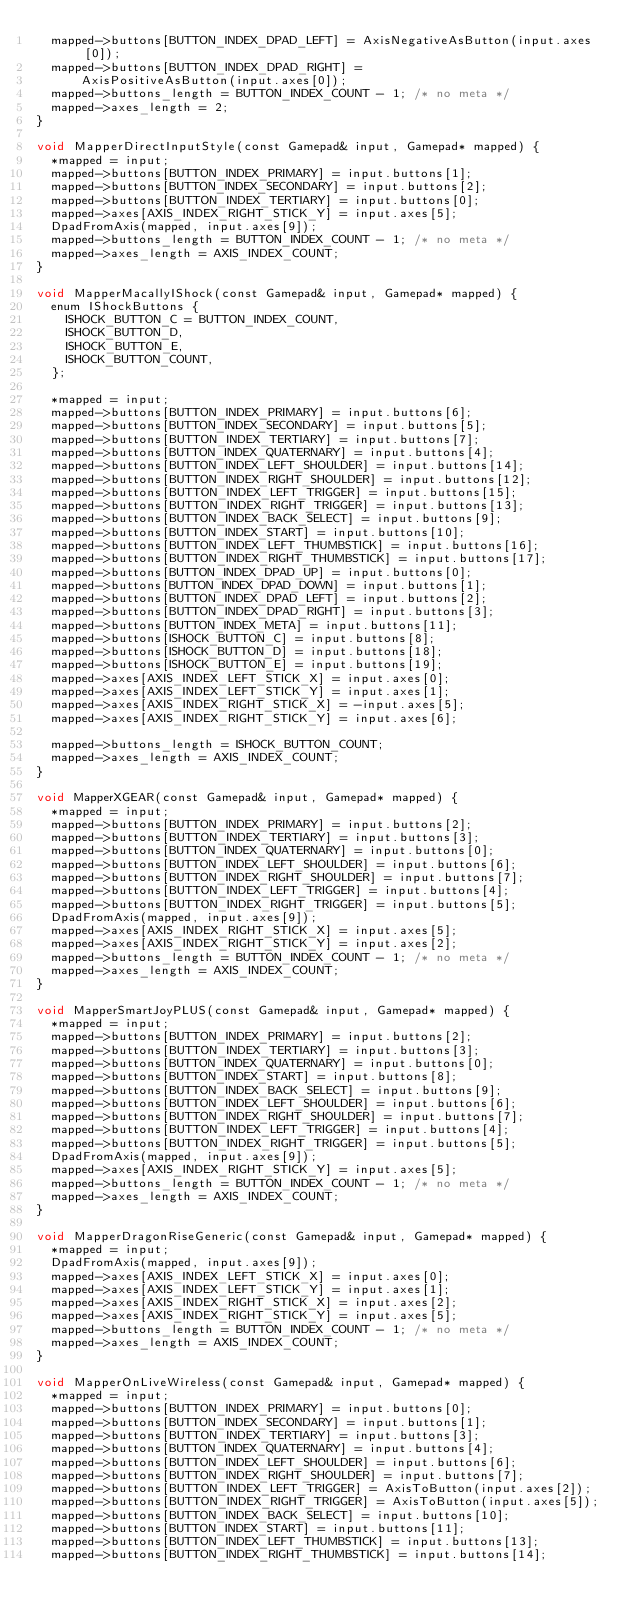Convert code to text. <code><loc_0><loc_0><loc_500><loc_500><_ObjectiveC_>  mapped->buttons[BUTTON_INDEX_DPAD_LEFT] = AxisNegativeAsButton(input.axes[0]);
  mapped->buttons[BUTTON_INDEX_DPAD_RIGHT] =
      AxisPositiveAsButton(input.axes[0]);
  mapped->buttons_length = BUTTON_INDEX_COUNT - 1; /* no meta */
  mapped->axes_length = 2;
}

void MapperDirectInputStyle(const Gamepad& input, Gamepad* mapped) {
  *mapped = input;
  mapped->buttons[BUTTON_INDEX_PRIMARY] = input.buttons[1];
  mapped->buttons[BUTTON_INDEX_SECONDARY] = input.buttons[2];
  mapped->buttons[BUTTON_INDEX_TERTIARY] = input.buttons[0];
  mapped->axes[AXIS_INDEX_RIGHT_STICK_Y] = input.axes[5];
  DpadFromAxis(mapped, input.axes[9]);
  mapped->buttons_length = BUTTON_INDEX_COUNT - 1; /* no meta */
  mapped->axes_length = AXIS_INDEX_COUNT;
}

void MapperMacallyIShock(const Gamepad& input, Gamepad* mapped) {
  enum IShockButtons {
    ISHOCK_BUTTON_C = BUTTON_INDEX_COUNT,
    ISHOCK_BUTTON_D,
    ISHOCK_BUTTON_E,
    ISHOCK_BUTTON_COUNT,
  };

  *mapped = input;
  mapped->buttons[BUTTON_INDEX_PRIMARY] = input.buttons[6];
  mapped->buttons[BUTTON_INDEX_SECONDARY] = input.buttons[5];
  mapped->buttons[BUTTON_INDEX_TERTIARY] = input.buttons[7];
  mapped->buttons[BUTTON_INDEX_QUATERNARY] = input.buttons[4];
  mapped->buttons[BUTTON_INDEX_LEFT_SHOULDER] = input.buttons[14];
  mapped->buttons[BUTTON_INDEX_RIGHT_SHOULDER] = input.buttons[12];
  mapped->buttons[BUTTON_INDEX_LEFT_TRIGGER] = input.buttons[15];
  mapped->buttons[BUTTON_INDEX_RIGHT_TRIGGER] = input.buttons[13];
  mapped->buttons[BUTTON_INDEX_BACK_SELECT] = input.buttons[9];
  mapped->buttons[BUTTON_INDEX_START] = input.buttons[10];
  mapped->buttons[BUTTON_INDEX_LEFT_THUMBSTICK] = input.buttons[16];
  mapped->buttons[BUTTON_INDEX_RIGHT_THUMBSTICK] = input.buttons[17];
  mapped->buttons[BUTTON_INDEX_DPAD_UP] = input.buttons[0];
  mapped->buttons[BUTTON_INDEX_DPAD_DOWN] = input.buttons[1];
  mapped->buttons[BUTTON_INDEX_DPAD_LEFT] = input.buttons[2];
  mapped->buttons[BUTTON_INDEX_DPAD_RIGHT] = input.buttons[3];
  mapped->buttons[BUTTON_INDEX_META] = input.buttons[11];
  mapped->buttons[ISHOCK_BUTTON_C] = input.buttons[8];
  mapped->buttons[ISHOCK_BUTTON_D] = input.buttons[18];
  mapped->buttons[ISHOCK_BUTTON_E] = input.buttons[19];
  mapped->axes[AXIS_INDEX_LEFT_STICK_X] = input.axes[0];
  mapped->axes[AXIS_INDEX_LEFT_STICK_Y] = input.axes[1];
  mapped->axes[AXIS_INDEX_RIGHT_STICK_X] = -input.axes[5];
  mapped->axes[AXIS_INDEX_RIGHT_STICK_Y] = input.axes[6];

  mapped->buttons_length = ISHOCK_BUTTON_COUNT;
  mapped->axes_length = AXIS_INDEX_COUNT;
}

void MapperXGEAR(const Gamepad& input, Gamepad* mapped) {
  *mapped = input;
  mapped->buttons[BUTTON_INDEX_PRIMARY] = input.buttons[2];
  mapped->buttons[BUTTON_INDEX_TERTIARY] = input.buttons[3];
  mapped->buttons[BUTTON_INDEX_QUATERNARY] = input.buttons[0];
  mapped->buttons[BUTTON_INDEX_LEFT_SHOULDER] = input.buttons[6];
  mapped->buttons[BUTTON_INDEX_RIGHT_SHOULDER] = input.buttons[7];
  mapped->buttons[BUTTON_INDEX_LEFT_TRIGGER] = input.buttons[4];
  mapped->buttons[BUTTON_INDEX_RIGHT_TRIGGER] = input.buttons[5];
  DpadFromAxis(mapped, input.axes[9]);
  mapped->axes[AXIS_INDEX_RIGHT_STICK_X] = input.axes[5];
  mapped->axes[AXIS_INDEX_RIGHT_STICK_Y] = input.axes[2];
  mapped->buttons_length = BUTTON_INDEX_COUNT - 1; /* no meta */
  mapped->axes_length = AXIS_INDEX_COUNT;
}

void MapperSmartJoyPLUS(const Gamepad& input, Gamepad* mapped) {
  *mapped = input;
  mapped->buttons[BUTTON_INDEX_PRIMARY] = input.buttons[2];
  mapped->buttons[BUTTON_INDEX_TERTIARY] = input.buttons[3];
  mapped->buttons[BUTTON_INDEX_QUATERNARY] = input.buttons[0];
  mapped->buttons[BUTTON_INDEX_START] = input.buttons[8];
  mapped->buttons[BUTTON_INDEX_BACK_SELECT] = input.buttons[9];
  mapped->buttons[BUTTON_INDEX_LEFT_SHOULDER] = input.buttons[6];
  mapped->buttons[BUTTON_INDEX_RIGHT_SHOULDER] = input.buttons[7];
  mapped->buttons[BUTTON_INDEX_LEFT_TRIGGER] = input.buttons[4];
  mapped->buttons[BUTTON_INDEX_RIGHT_TRIGGER] = input.buttons[5];
  DpadFromAxis(mapped, input.axes[9]);
  mapped->axes[AXIS_INDEX_RIGHT_STICK_Y] = input.axes[5];
  mapped->buttons_length = BUTTON_INDEX_COUNT - 1; /* no meta */
  mapped->axes_length = AXIS_INDEX_COUNT;
}

void MapperDragonRiseGeneric(const Gamepad& input, Gamepad* mapped) {
  *mapped = input;
  DpadFromAxis(mapped, input.axes[9]);
  mapped->axes[AXIS_INDEX_LEFT_STICK_X] = input.axes[0];
  mapped->axes[AXIS_INDEX_LEFT_STICK_Y] = input.axes[1];
  mapped->axes[AXIS_INDEX_RIGHT_STICK_X] = input.axes[2];
  mapped->axes[AXIS_INDEX_RIGHT_STICK_Y] = input.axes[5];
  mapped->buttons_length = BUTTON_INDEX_COUNT - 1; /* no meta */
  mapped->axes_length = AXIS_INDEX_COUNT;
}

void MapperOnLiveWireless(const Gamepad& input, Gamepad* mapped) {
  *mapped = input;
  mapped->buttons[BUTTON_INDEX_PRIMARY] = input.buttons[0];
  mapped->buttons[BUTTON_INDEX_SECONDARY] = input.buttons[1];
  mapped->buttons[BUTTON_INDEX_TERTIARY] = input.buttons[3];
  mapped->buttons[BUTTON_INDEX_QUATERNARY] = input.buttons[4];
  mapped->buttons[BUTTON_INDEX_LEFT_SHOULDER] = input.buttons[6];
  mapped->buttons[BUTTON_INDEX_RIGHT_SHOULDER] = input.buttons[7];
  mapped->buttons[BUTTON_INDEX_LEFT_TRIGGER] = AxisToButton(input.axes[2]);
  mapped->buttons[BUTTON_INDEX_RIGHT_TRIGGER] = AxisToButton(input.axes[5]);
  mapped->buttons[BUTTON_INDEX_BACK_SELECT] = input.buttons[10];
  mapped->buttons[BUTTON_INDEX_START] = input.buttons[11];
  mapped->buttons[BUTTON_INDEX_LEFT_THUMBSTICK] = input.buttons[13];
  mapped->buttons[BUTTON_INDEX_RIGHT_THUMBSTICK] = input.buttons[14];</code> 